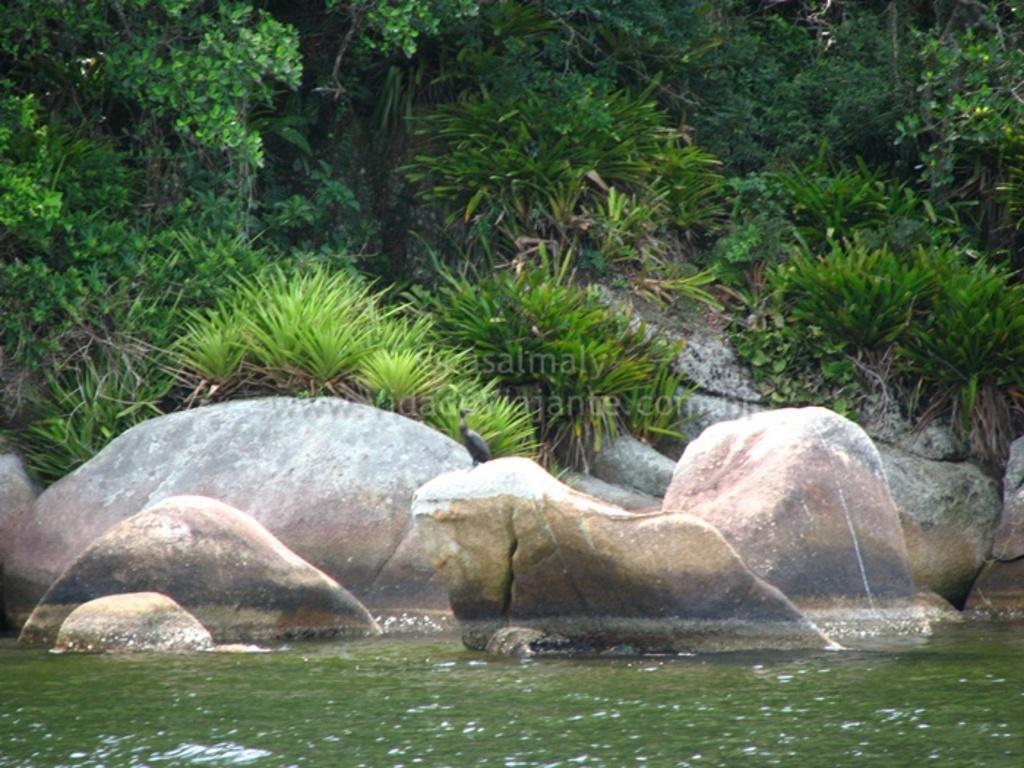What is at the bottom of the image? There is water at the bottom of the image. What is located near the water? There are rocks beside the water. What can be seen on one of the rocks? A bird is sitting on one of the rocks. What type of vegetation is visible in the background of the image? There are plants and trees in the background of the image. What type of copper pan can be seen in the image? There is no copper pan present in the image. 